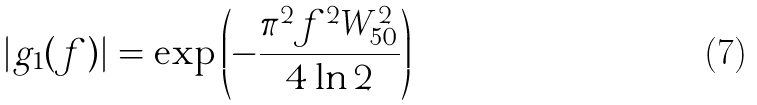Convert formula to latex. <formula><loc_0><loc_0><loc_500><loc_500>| g _ { 1 } ( f ) | = \exp \left ( - \frac { \pi ^ { 2 } f ^ { 2 } W _ { 5 0 } ^ { 2 } } { 4 \ln 2 } \right )</formula> 